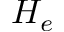Convert formula to latex. <formula><loc_0><loc_0><loc_500><loc_500>H _ { e }</formula> 